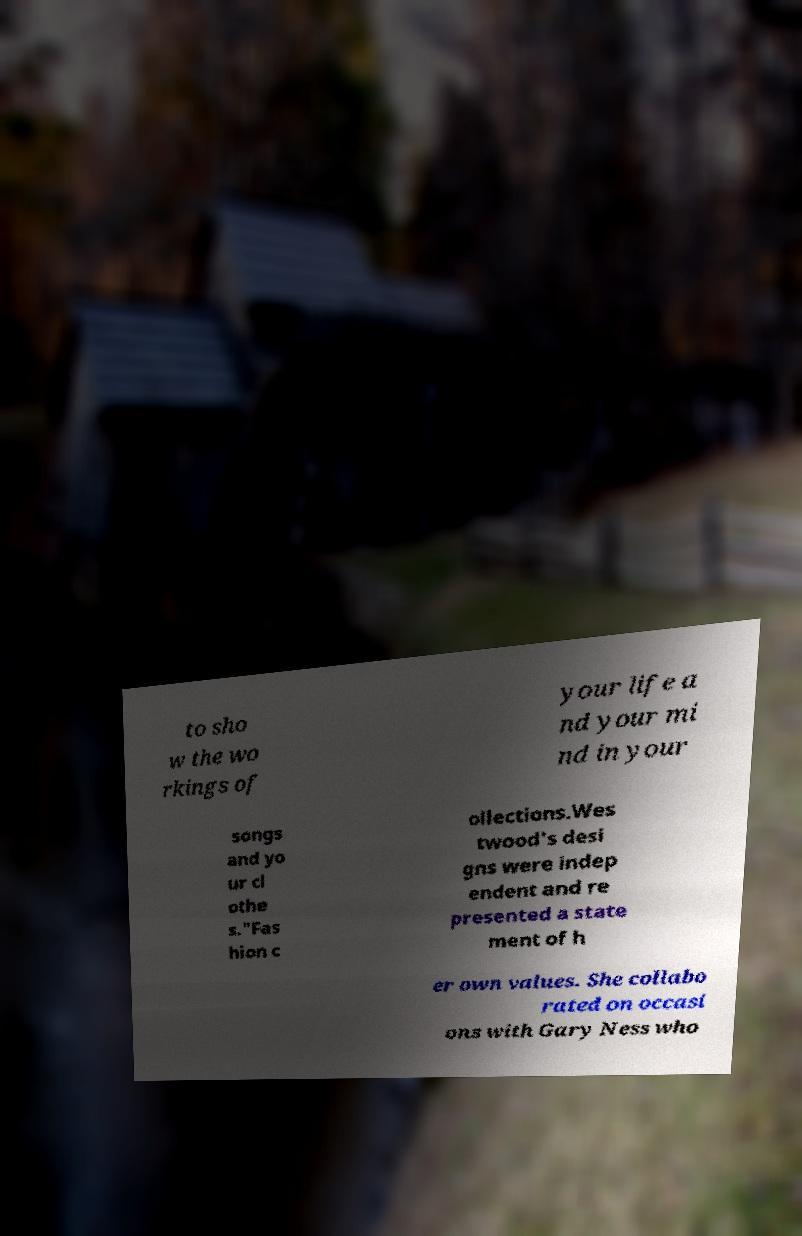For documentation purposes, I need the text within this image transcribed. Could you provide that? to sho w the wo rkings of your life a nd your mi nd in your songs and yo ur cl othe s."Fas hion c ollections.Wes twood's desi gns were indep endent and re presented a state ment of h er own values. She collabo rated on occasi ons with Gary Ness who 